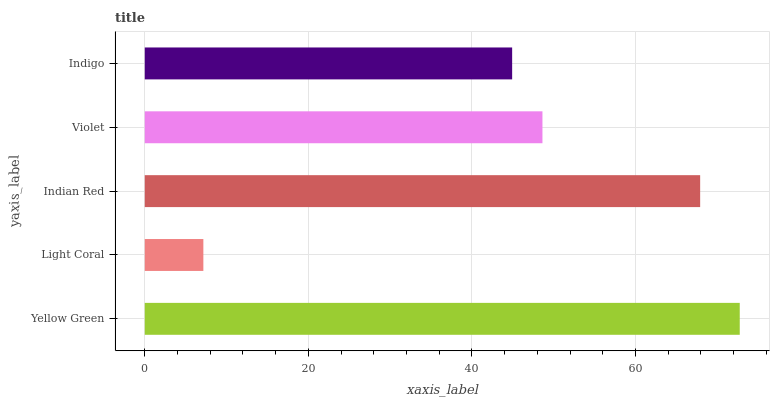Is Light Coral the minimum?
Answer yes or no. Yes. Is Yellow Green the maximum?
Answer yes or no. Yes. Is Indian Red the minimum?
Answer yes or no. No. Is Indian Red the maximum?
Answer yes or no. No. Is Indian Red greater than Light Coral?
Answer yes or no. Yes. Is Light Coral less than Indian Red?
Answer yes or no. Yes. Is Light Coral greater than Indian Red?
Answer yes or no. No. Is Indian Red less than Light Coral?
Answer yes or no. No. Is Violet the high median?
Answer yes or no. Yes. Is Violet the low median?
Answer yes or no. Yes. Is Indigo the high median?
Answer yes or no. No. Is Indigo the low median?
Answer yes or no. No. 